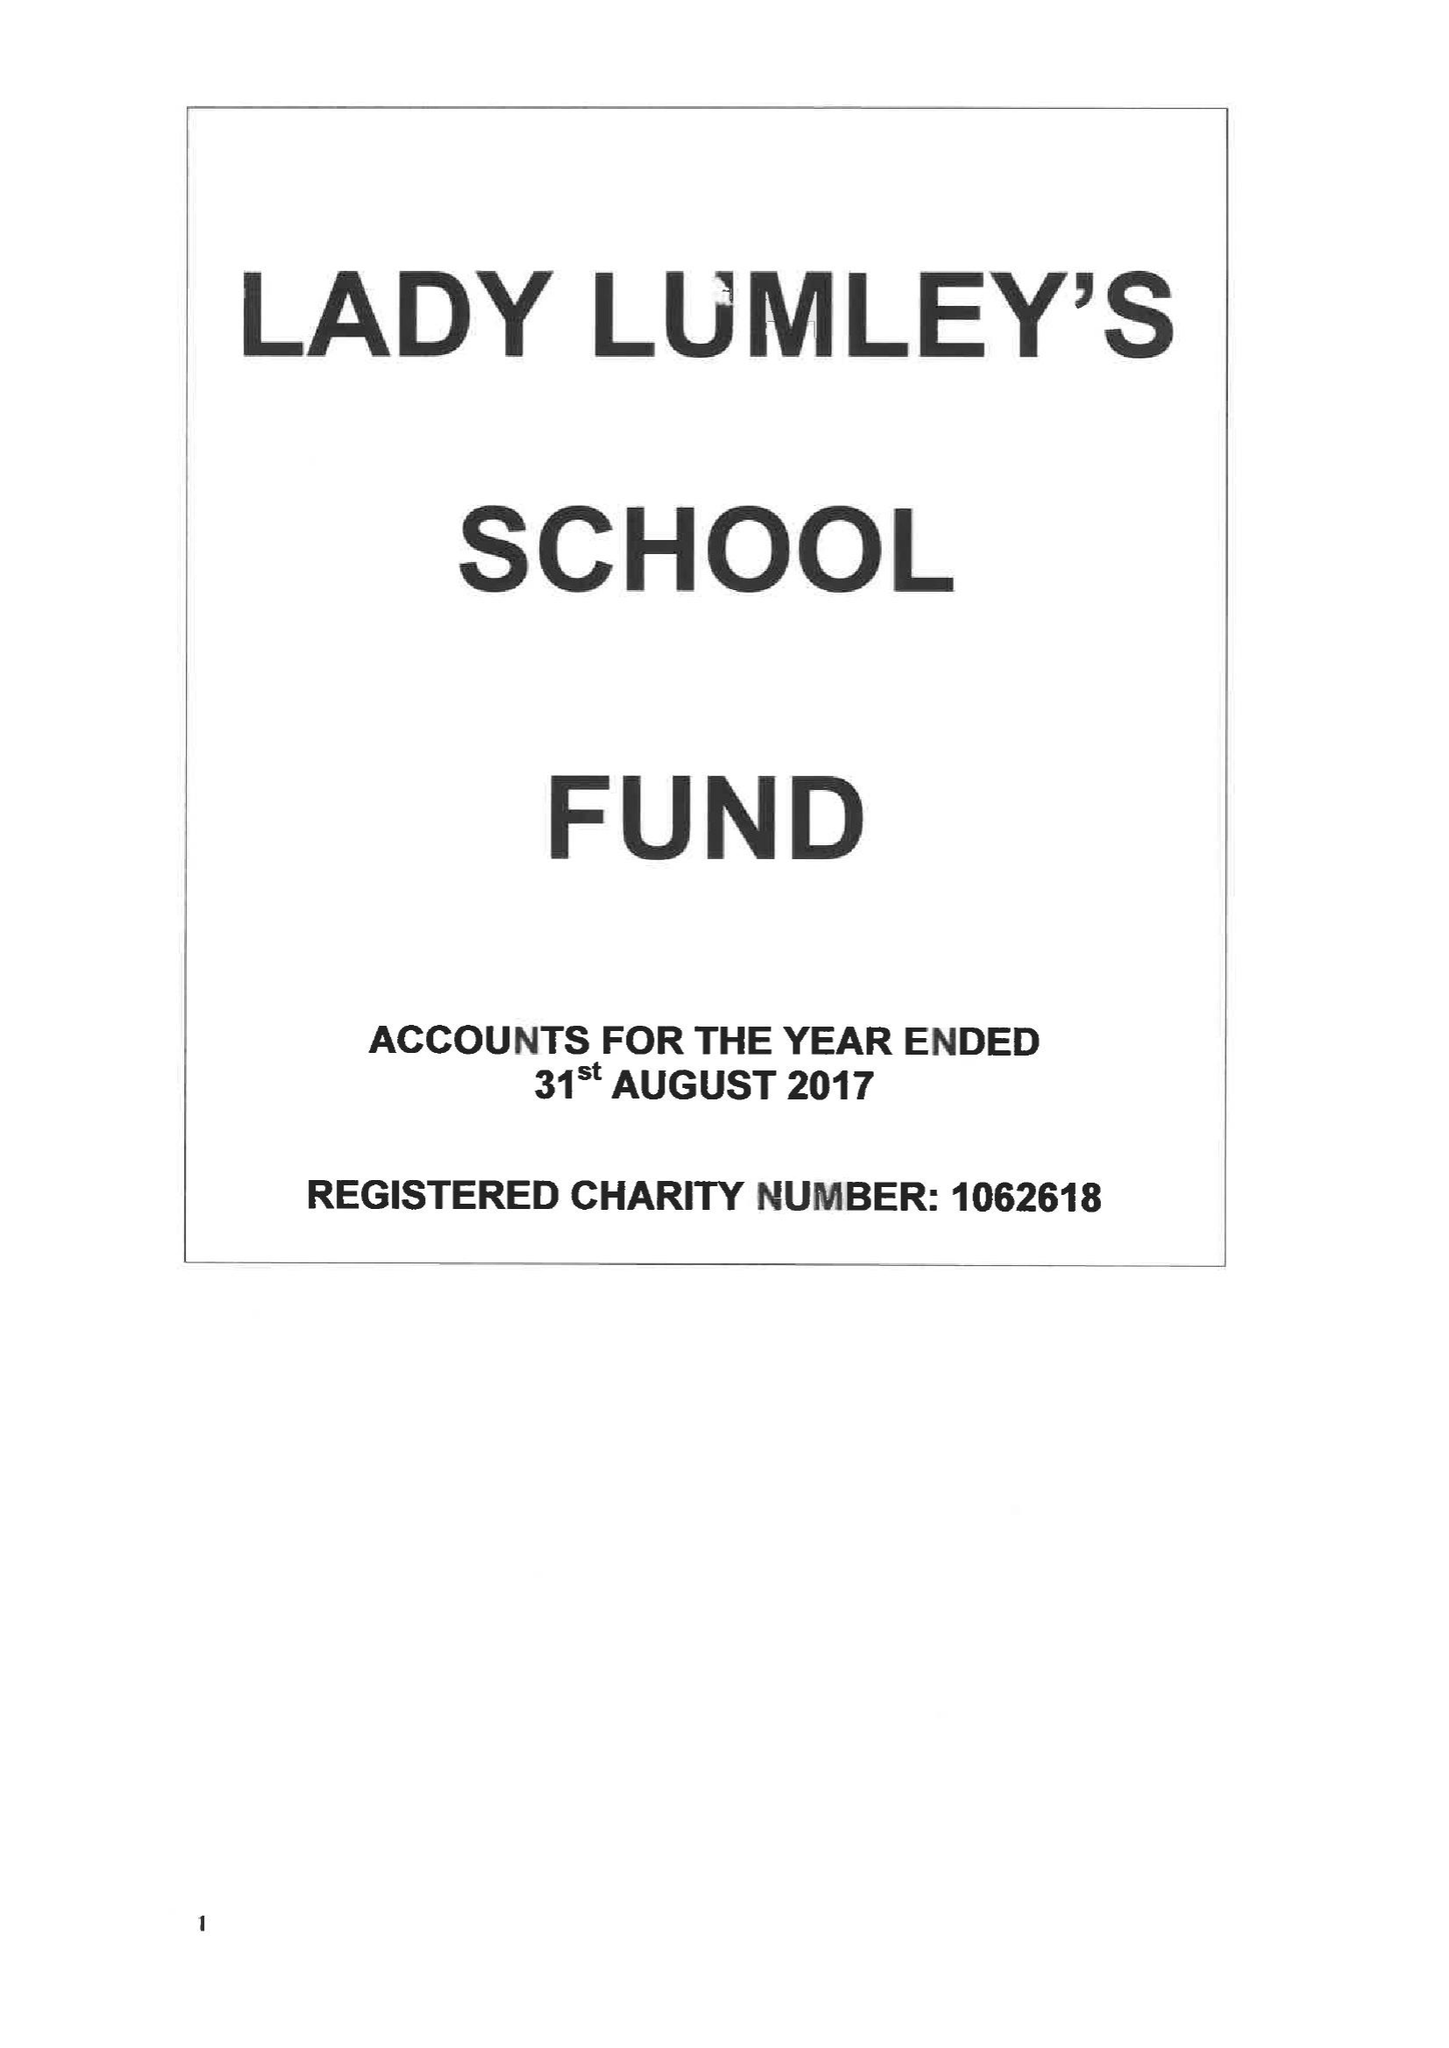What is the value for the income_annually_in_british_pounds?
Answer the question using a single word or phrase. 65857.00 